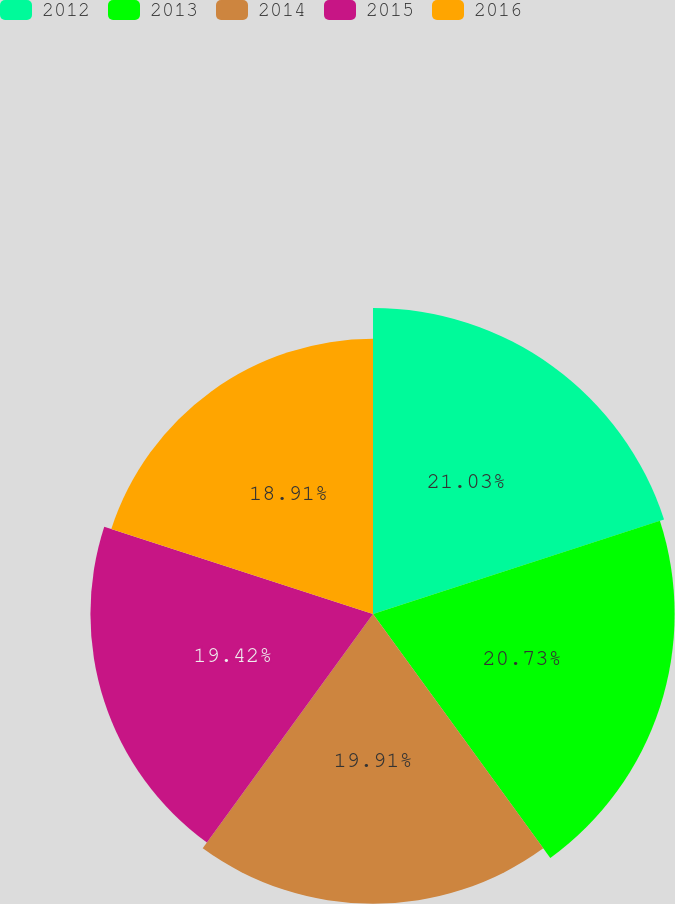Convert chart. <chart><loc_0><loc_0><loc_500><loc_500><pie_chart><fcel>2012<fcel>2013<fcel>2014<fcel>2015<fcel>2016<nl><fcel>21.03%<fcel>20.73%<fcel>19.91%<fcel>19.42%<fcel>18.91%<nl></chart> 